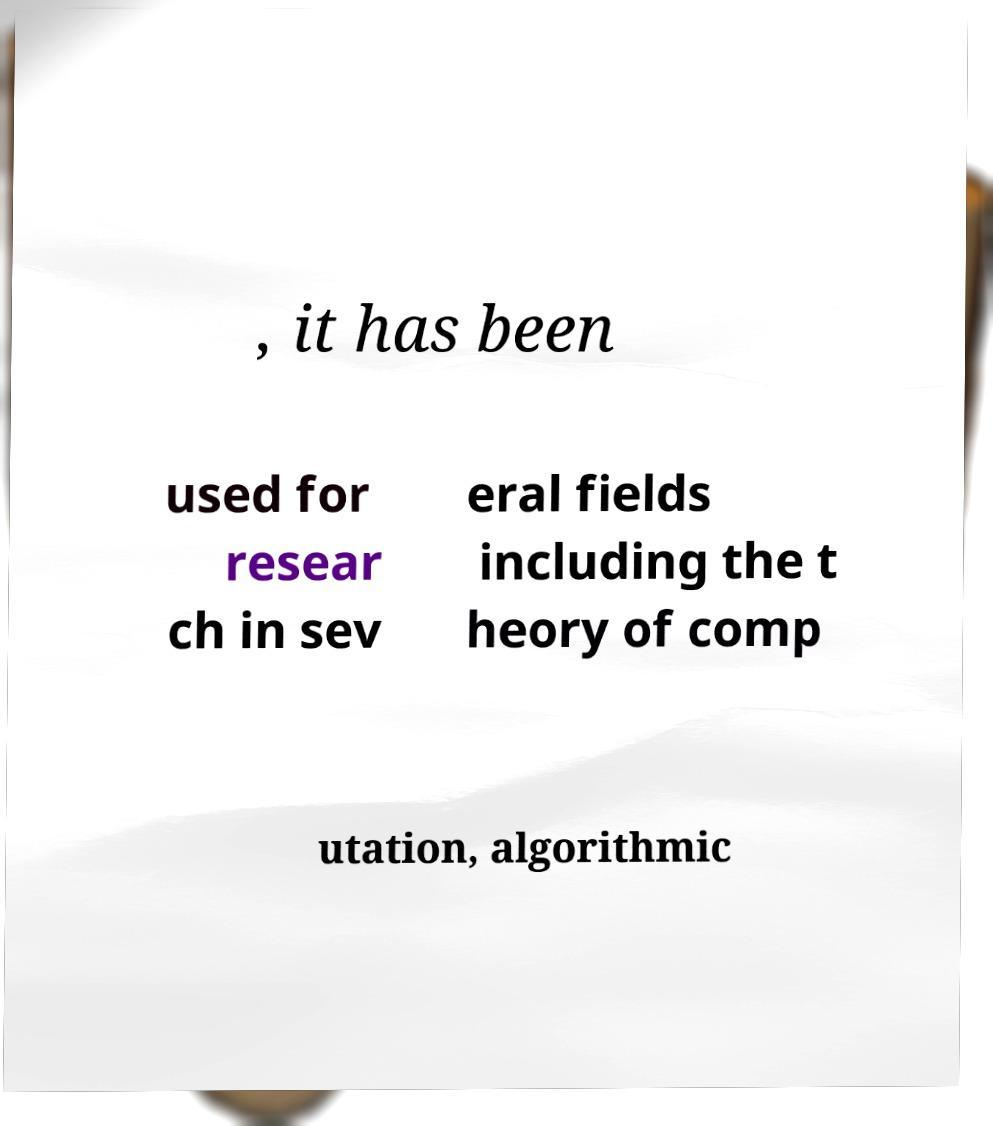What messages or text are displayed in this image? I need them in a readable, typed format. , it has been used for resear ch in sev eral fields including the t heory of comp utation, algorithmic 